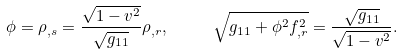<formula> <loc_0><loc_0><loc_500><loc_500>\phi = \rho _ { , s } = \frac { \sqrt { 1 - v ^ { 2 } } } { \sqrt { g _ { 1 1 } } } \rho _ { , r } , \text { } \text { } \text { } \text { } \sqrt { g _ { 1 1 } + \phi ^ { 2 } f _ { , r } ^ { 2 } } = \frac { \sqrt { g _ { 1 1 } } } { \sqrt { 1 - v ^ { 2 } } } .</formula> 